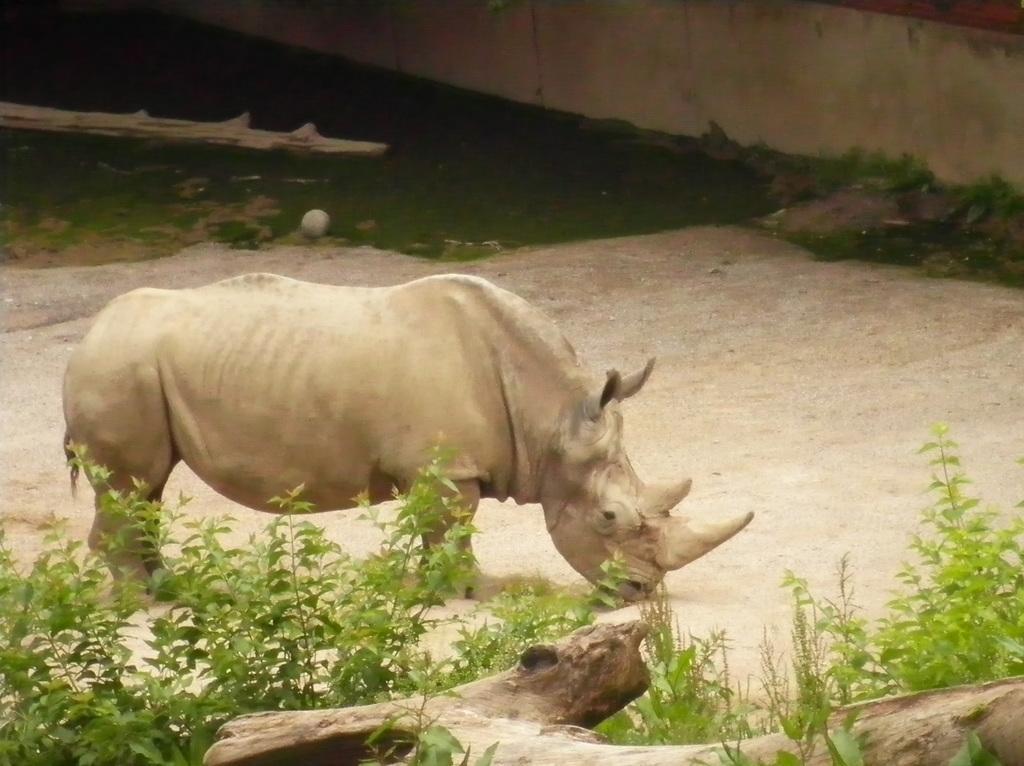Can you describe this image briefly? In this picture we can see rhinoceros. And these are the plants. And there is a wall. 